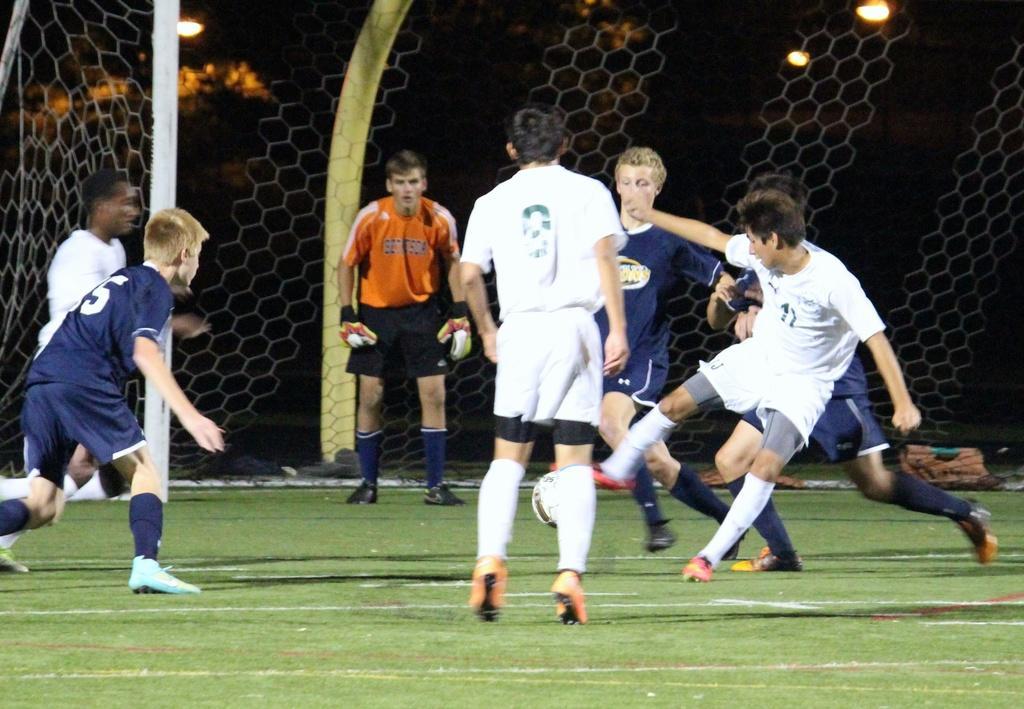How would you summarize this image in a sentence or two? In this image I can see the group of people are playing the football. In the background there are few lights and the net. 